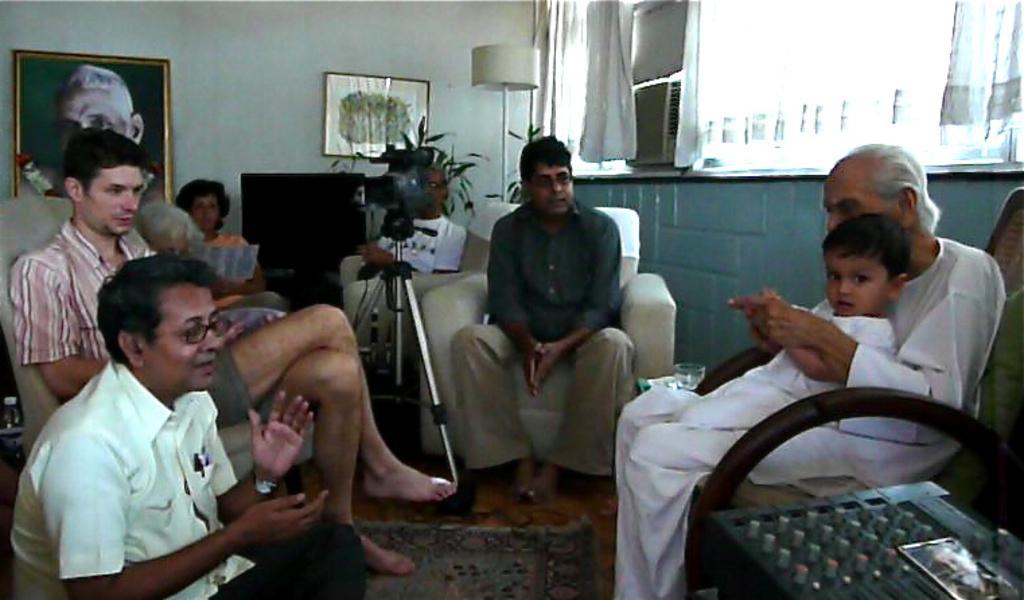Describe this image in one or two sentences. In this picture I can see there are few people sitting and on to right this person is holding a boy and there is a camera attached to a stand and in the backdrop there is a wall, there are photo frames placed on the wall. 